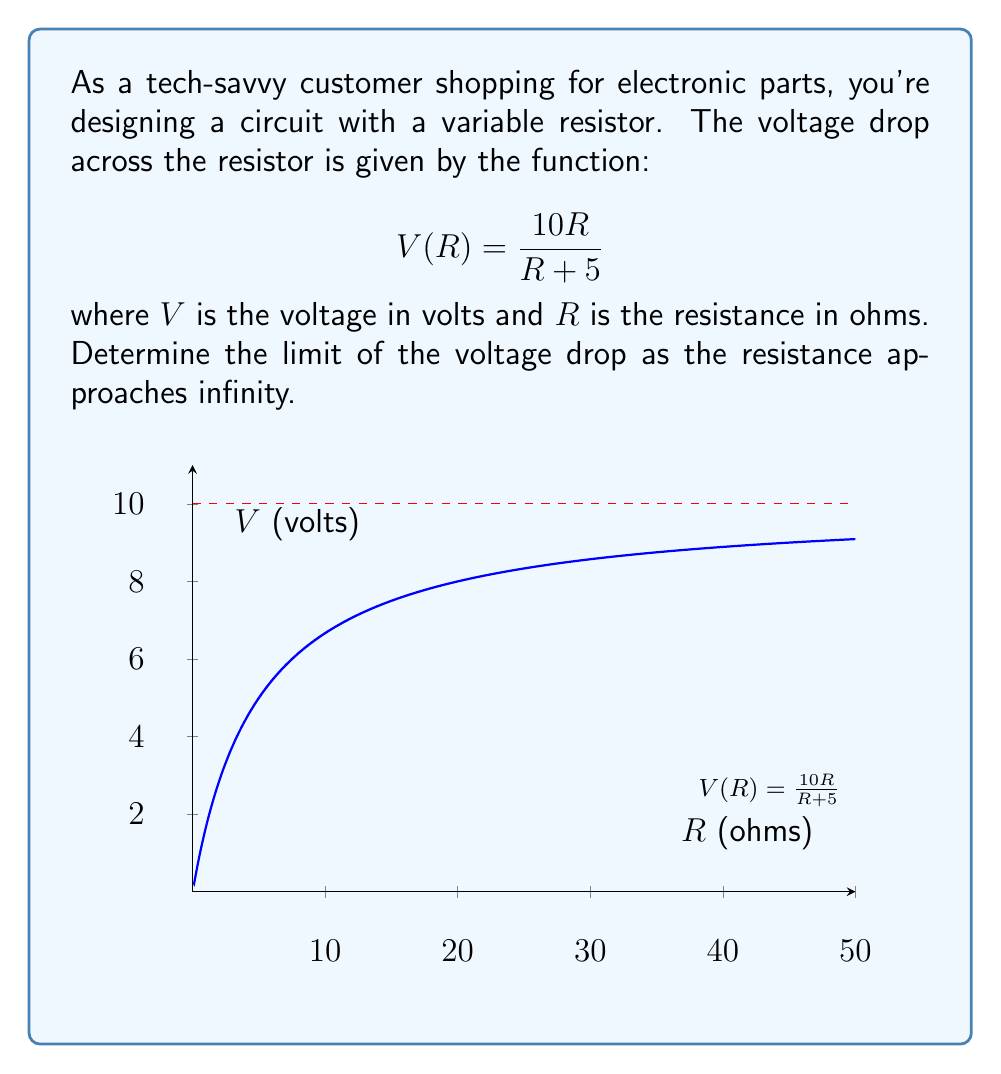What is the answer to this math problem? To find the limit of $V(R)$ as $R$ approaches infinity, we follow these steps:

1) First, let's write out our limit:
   $$\lim_{R \to \infty} \frac{10R}{R + 5}$$

2) As $R$ approaches infinity, both the numerator and denominator grow infinitely large. This is an indeterminate form of type $\frac{\infty}{\infty}$.

3) To resolve this, we can divide both the numerator and denominator by the highest power of $R$ in the denominator, which is $R$:

   $$\lim_{R \to \infty} \frac{10R}{R + 5} = \lim_{R \to \infty} \frac{10R/R}{(R + 5)/R} = \lim_{R \to \infty} \frac{10}{1 + 5/R}$$

4) Now, as $R$ approaches infinity, $5/R$ approaches 0:

   $$\lim_{R \to \infty} \frac{10}{1 + 5/R} = \frac{10}{1 + 0} = 10$$

5) Therefore, the voltage drop across the resistor approaches 10 volts as the resistance approaches infinity.

This makes sense physically: as the resistance increases, the voltage drop across the resistor approaches the total voltage of the circuit, which in this case is 10 volts.
Answer: $10$ volts 